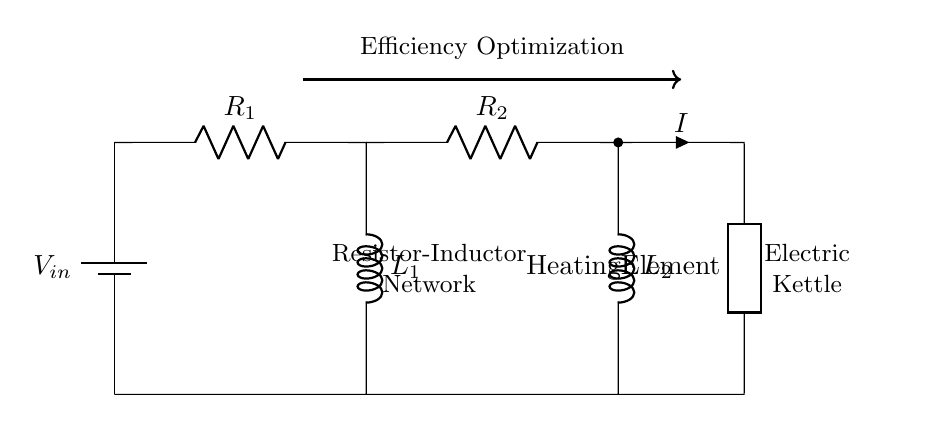What are the components in this circuit? The circuit contains two resistors, two inductors, and a heating element. The resistors are labeled as R1 and R2, the inductors as L1 and L2, and the heating element is labeled as H.
Answer: Resistors, inductors, heating element What is the role of the inductors in this circuit? The inductors L1 and L2 are used to manage the current flow and can help in smoothing out fluctuations, which ultimately contributes to the efficiency of the heating process.
Answer: Current management What is the current flowing through the circuit? The current is indicated by the label I next to the current direction arrow. It represents the flow of electricity through the heating element and the network.
Answer: I How does this circuit optimize heating element efficiency? The combination of resistors and inductors can adjust current and voltage characteristics in order to maximize heat generated while minimizing energy loss, thus optimizing efficiency.
Answer: Adjusts current and voltage What is the connection type used in the circuit? The circuit employs series connections between the components, meaning that the resistors and inductors are connected in a sequential manner along the same path.
Answer: Series Which component is directly connected to the heating element? The heating element is directly connected after the second inductor L2, and also linked to the current path I from the network.
Answer: L2 